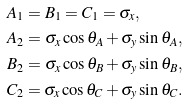<formula> <loc_0><loc_0><loc_500><loc_500>& A _ { 1 } = B _ { 1 } = C _ { 1 } = \sigma _ { x } , \\ & A _ { 2 } = \sigma _ { x } \cos \theta _ { A } + \sigma _ { y } \sin \theta _ { A } , \\ & B _ { 2 } = \sigma _ { x } \cos \theta _ { B } + \sigma _ { y } \sin \theta _ { B } , \\ & C _ { 2 } = \sigma _ { x } \cos \theta _ { C } + \sigma _ { y } \sin \theta _ { C } .</formula> 